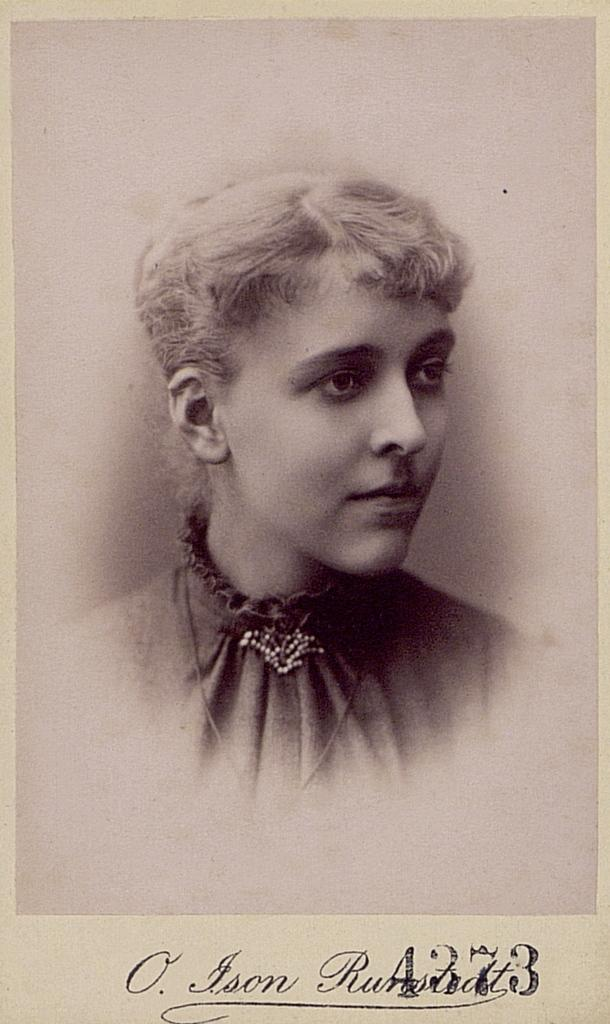What is present in the image? There is a poster in the image. What can be seen on the poster? The poster contains an image and text. What type of tub is depicted on the poster? There is no tub present on the poster; it contains an image and text, but the content of the image is not specified in the given facts. 